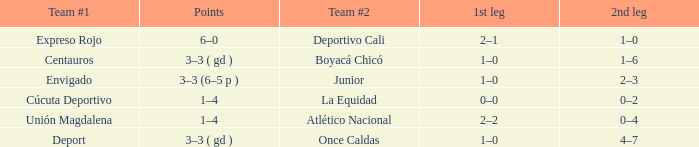What is the 1st leg with a junior team #2? 1–0. 